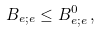Convert formula to latex. <formula><loc_0><loc_0><loc_500><loc_500>B _ { e ; e } \leq B _ { e ; e } ^ { 0 } \, ,</formula> 